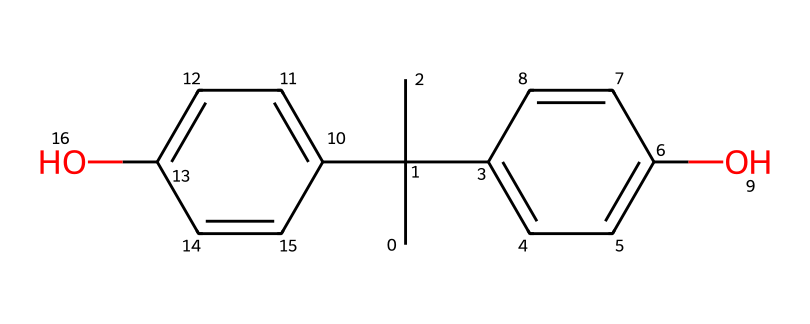What is the molecular formula of bisphenol A? To determine the molecular formula, we count all the carbon (C), hydrogen (H), and oxygen (O) atoms in the structure represented by the SMILES. There are 15 carbon atoms, 16 hydrogen atoms, and 2 oxygen atoms. Thus, the molecular formula is C15H16O2.
Answer: C15H16O2 How many hydroxyl groups does bisphenol A contain? The hydroxyl group (–OH) can be identified by looking for oxygen atoms bonded to a carbon that also has a hydrogen atom attached. In the structure, there are two such groups indicated in the SMILES representation.
Answer: 2 What type of compound is bisphenol A? Bisphenol A is a type of phenolic compound due to its structure, which features two phenolic rings and hydroxyl groups. This classification is evident from the presence of the two aromatic rings connected by the carbon chain.
Answer: phenolic What is the total number of rings in bisphenol A? By examining the structural depiction, we can see that there are two distinct phenolic rings interconnected by a carbon bridge. Therefore, the total number of rings in the compound is 2.
Answer: 2 How many double bonds are present in bisphenol A? In the chemical structure, double bonds are indicated between carbon atoms within the rings. By analyzing the structure in the SMILES, we identify a total of 4 double bonds located in the aromatic systems of the two rings.
Answer: 4 What property is likely affected by the presence of hydroxyl groups in bisphenol A? The hydroxyl groups in organic compounds typically influence solubility and reactivity. Specifically, the presence of hydroxyl groups in bisphenol A affects its solubility in water and enhances its interaction with other substances due to hydrogen bonding.
Answer: solubility 